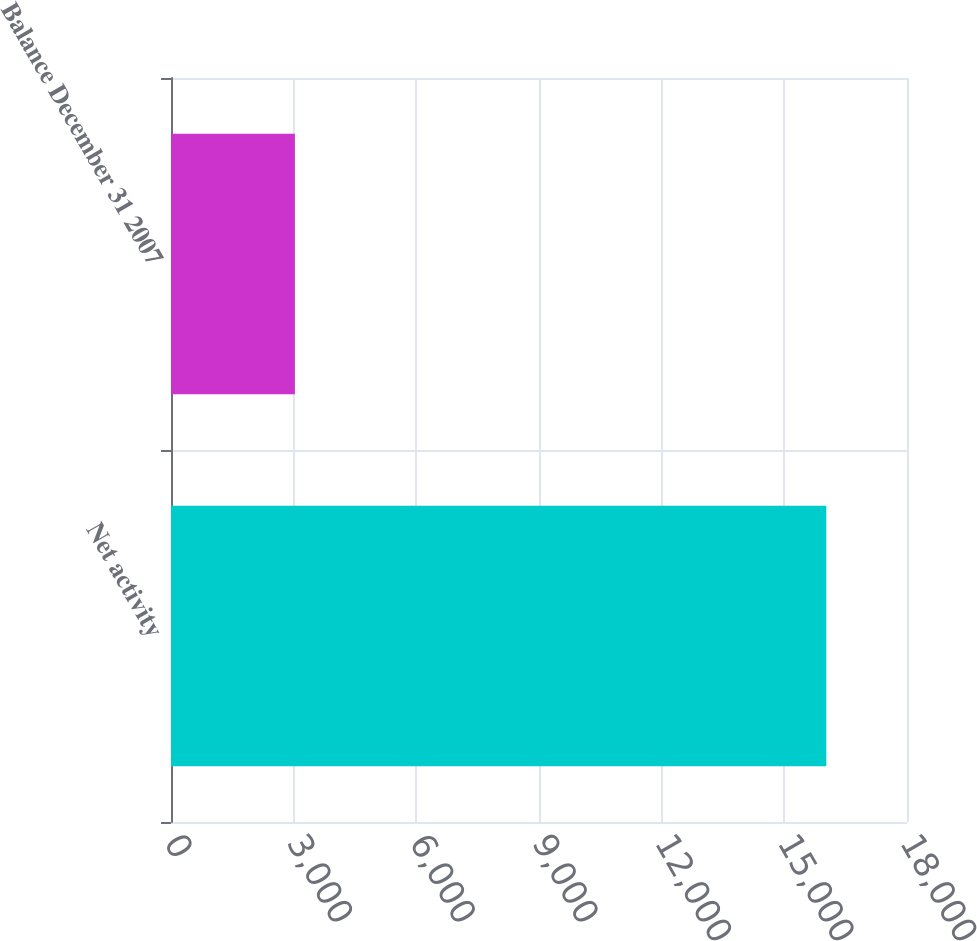<chart> <loc_0><loc_0><loc_500><loc_500><bar_chart><fcel>Net activity<fcel>Balance December 31 2007<nl><fcel>16027<fcel>3030<nl></chart> 